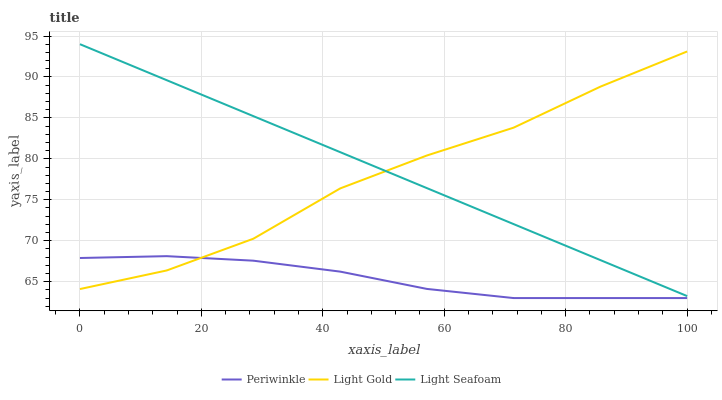Does Light Seafoam have the minimum area under the curve?
Answer yes or no. No. Does Periwinkle have the maximum area under the curve?
Answer yes or no. No. Is Periwinkle the smoothest?
Answer yes or no. No. Is Periwinkle the roughest?
Answer yes or no. No. Does Light Seafoam have the lowest value?
Answer yes or no. No. Does Periwinkle have the highest value?
Answer yes or no. No. Is Periwinkle less than Light Seafoam?
Answer yes or no. Yes. Is Light Seafoam greater than Periwinkle?
Answer yes or no. Yes. Does Periwinkle intersect Light Seafoam?
Answer yes or no. No. 